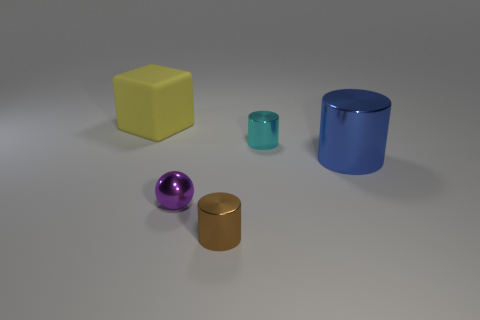Subtract all small cyan metallic cylinders. How many cylinders are left? 2 Add 5 large yellow objects. How many objects exist? 10 Subtract all blue cylinders. How many cylinders are left? 2 Subtract all balls. How many objects are left? 4 Subtract all gray balls. How many red cubes are left? 0 Subtract all large gray rubber cubes. Subtract all cyan shiny cylinders. How many objects are left? 4 Add 1 brown shiny things. How many brown shiny things are left? 2 Add 3 tiny cyan cylinders. How many tiny cyan cylinders exist? 4 Subtract 0 red cylinders. How many objects are left? 5 Subtract 3 cylinders. How many cylinders are left? 0 